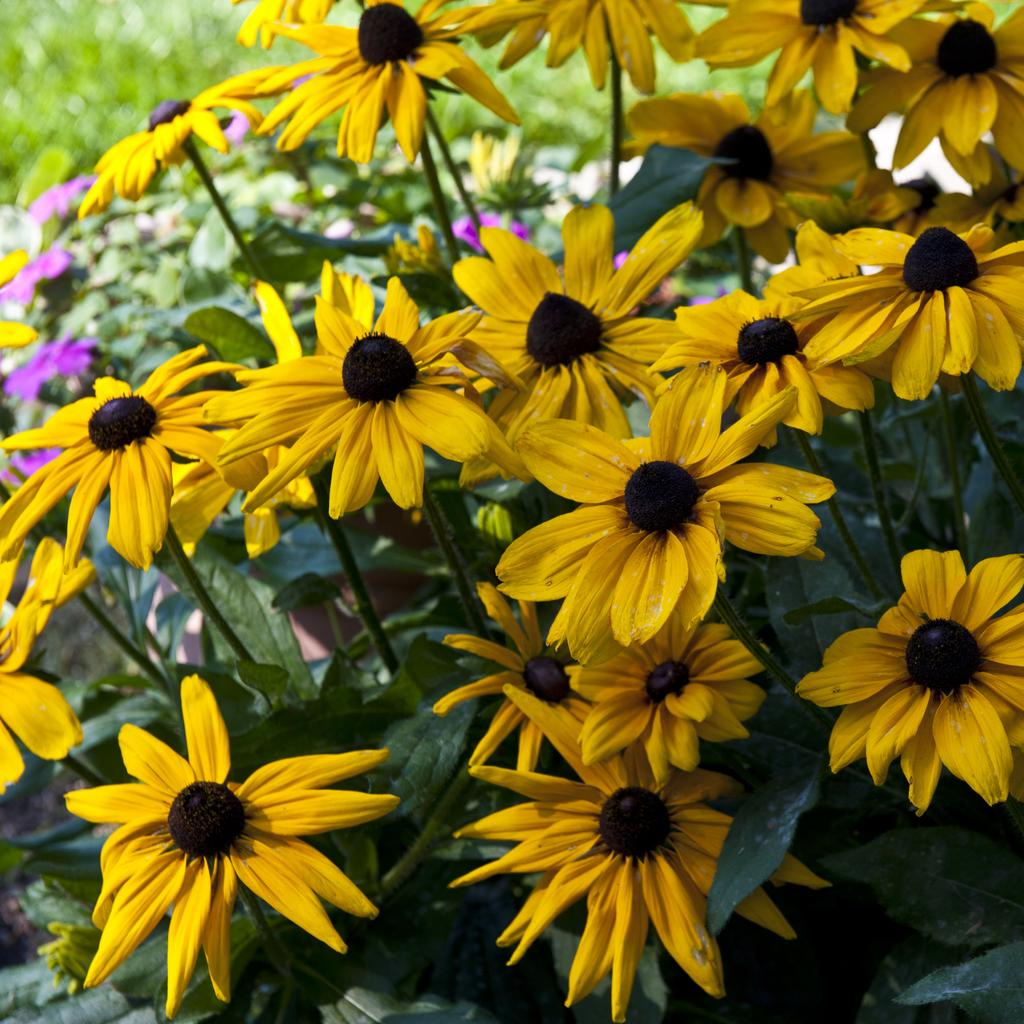What type of living organisms can be seen in the image? There are flowers and plants visible in the image. Can you describe the plants in the image? The plants in the image are not specified, but they are present alongside the flowers. What type of furniture is visible in the image? There is no furniture present in the image; it only features flowers and plants. What color is the dress worn by the plant in the image? There is no plant wearing a dress in the image; plants do not wear clothing. 